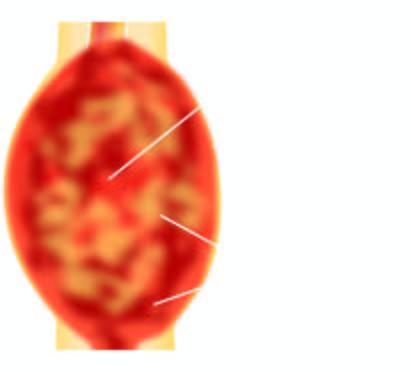s cut surface of the tumour grey-white, cystic, soft and friable?
Answer the question using a single word or phrase. Yes 